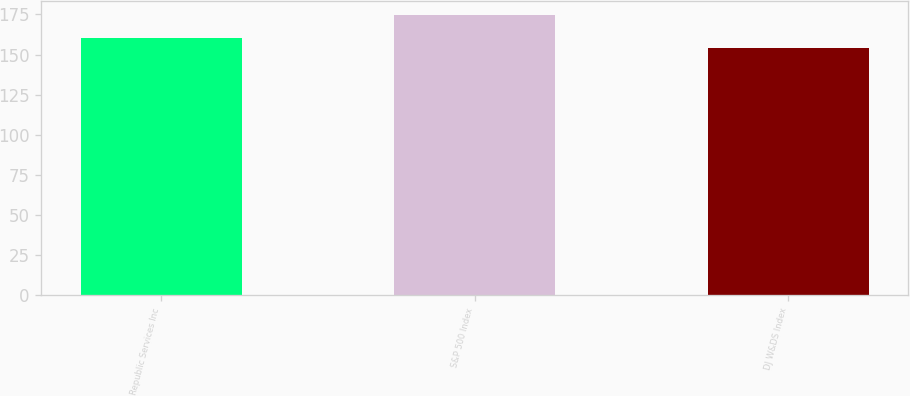<chart> <loc_0><loc_0><loc_500><loc_500><bar_chart><fcel>Republic Services Inc<fcel>S&P 500 Index<fcel>DJ W&DS Index<nl><fcel>160.05<fcel>174.6<fcel>154.2<nl></chart> 